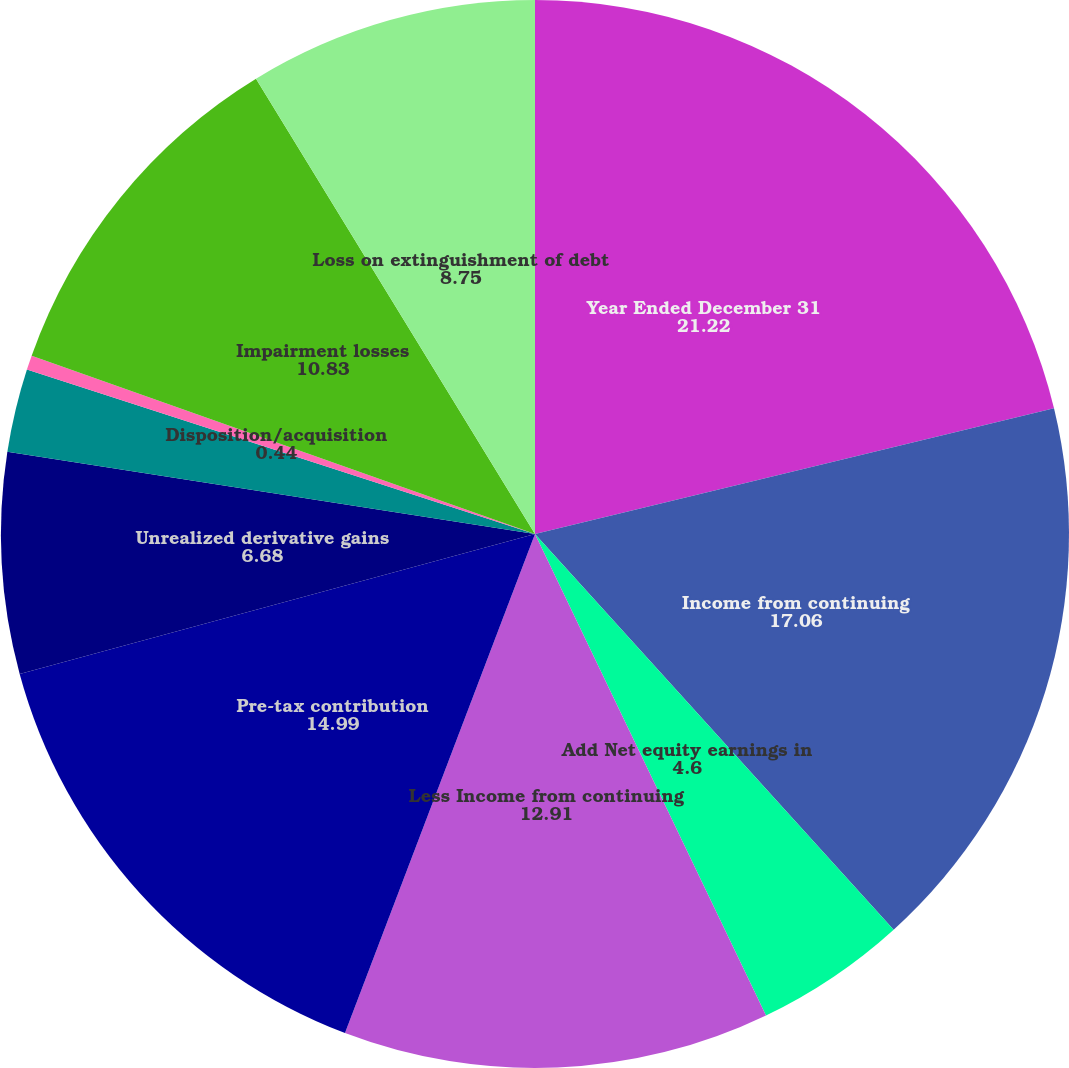<chart> <loc_0><loc_0><loc_500><loc_500><pie_chart><fcel>Year Ended December 31<fcel>Income from continuing<fcel>Add Net equity earnings in<fcel>Less Income from continuing<fcel>Pre-tax contribution<fcel>Unrealized derivative gains<fcel>Unrealized foreign currency<fcel>Disposition/acquisition<fcel>Impairment losses<fcel>Loss on extinguishment of debt<nl><fcel>21.22%<fcel>17.06%<fcel>4.6%<fcel>12.91%<fcel>14.99%<fcel>6.68%<fcel>2.52%<fcel>0.44%<fcel>10.83%<fcel>8.75%<nl></chart> 